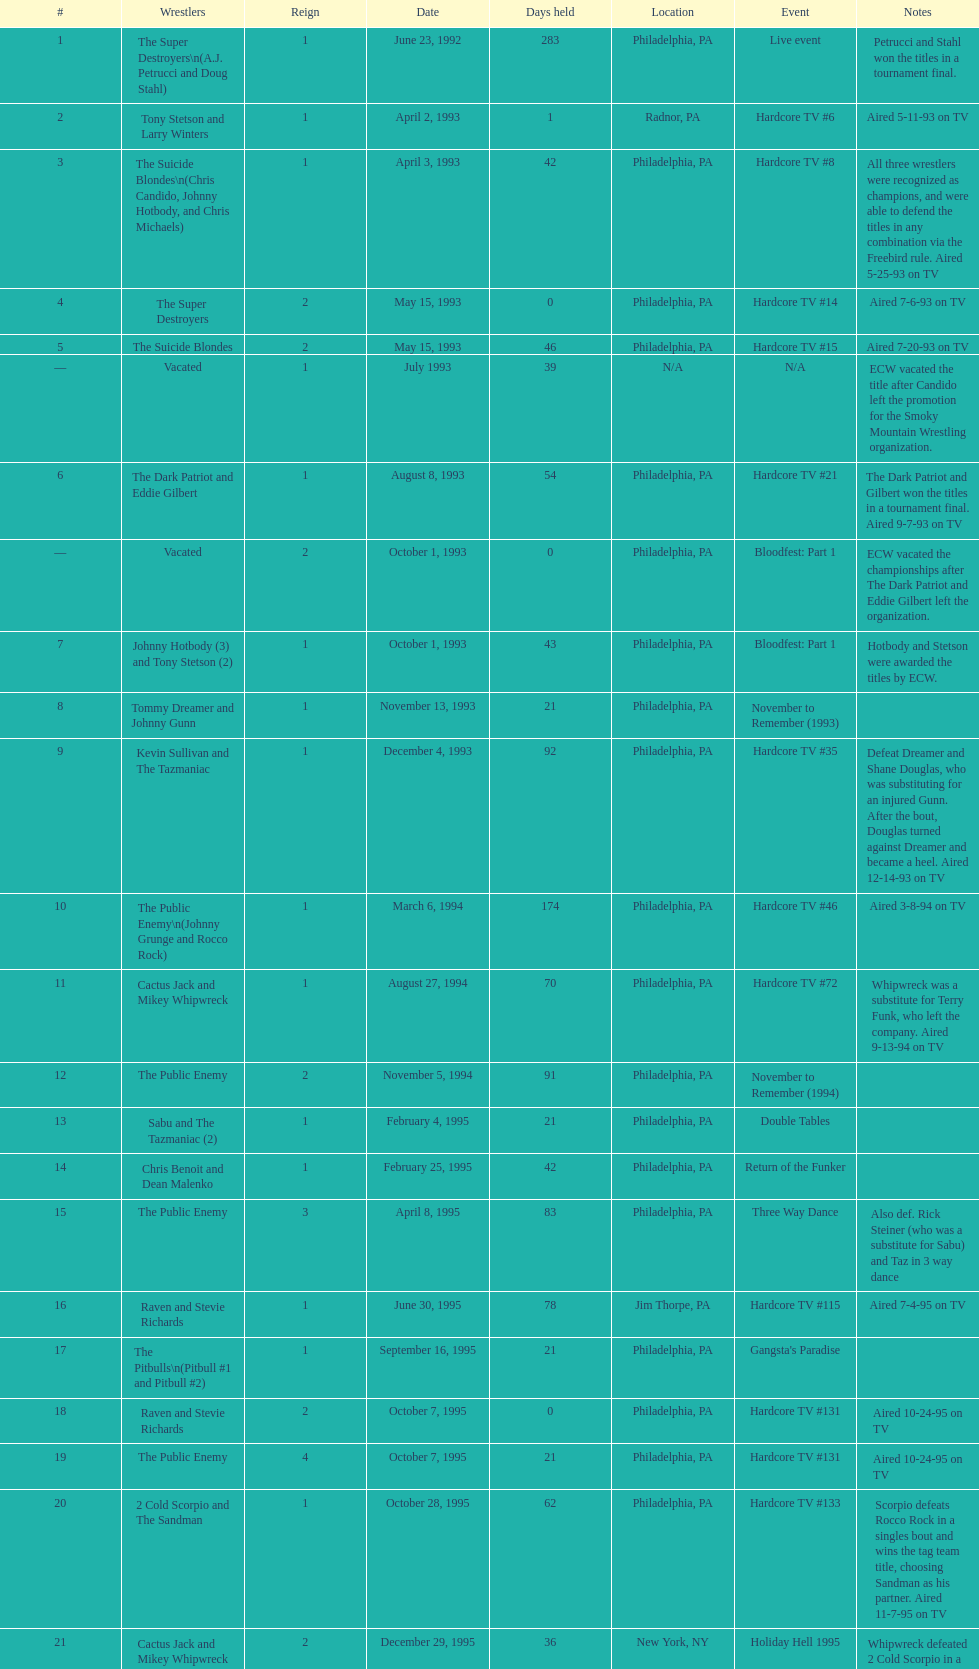What is the next event after hardcore tv #15? Hardcore TV #21. 